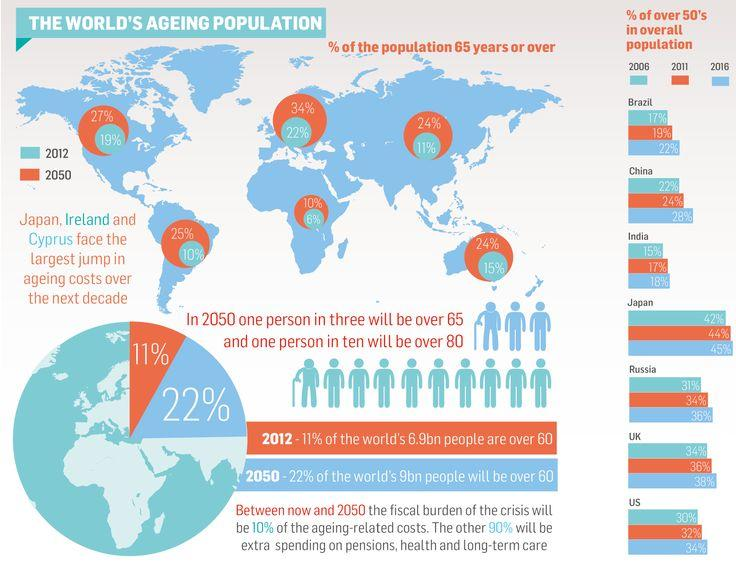Mention a couple of crucial points in this snapshot. According to data from 2012, North America has the highest percentage of its population above the age of 65, at 19%. In 2050, it is projected that the population of senior citizens in Australia will comprise 24% of the total population. According to projections, in 2050, approximately 25% of the population in South America will be individuals who are over the age of 65. 